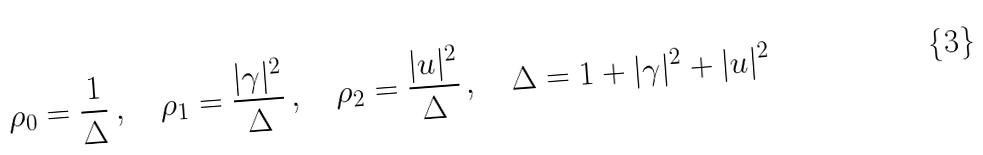<formula> <loc_0><loc_0><loc_500><loc_500>\rho _ { 0 } = \frac { 1 } { \Delta } \, , \quad \rho _ { 1 } = \frac { | \gamma | ^ { 2 } } { \Delta } \, , \quad \rho _ { 2 } = \frac { | u | ^ { 2 } } { \Delta } \, , \quad \Delta = 1 + | \gamma | ^ { 2 } + | u | ^ { 2 }</formula> 